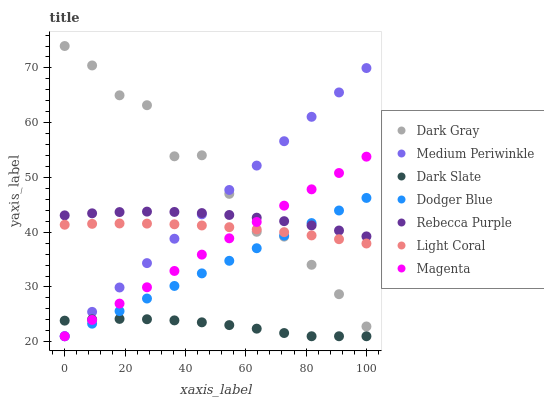Does Dark Slate have the minimum area under the curve?
Answer yes or no. Yes. Does Dark Gray have the maximum area under the curve?
Answer yes or no. Yes. Does Medium Periwinkle have the minimum area under the curve?
Answer yes or no. No. Does Medium Periwinkle have the maximum area under the curve?
Answer yes or no. No. Is Magenta the smoothest?
Answer yes or no. Yes. Is Dark Gray the roughest?
Answer yes or no. Yes. Is Medium Periwinkle the smoothest?
Answer yes or no. No. Is Medium Periwinkle the roughest?
Answer yes or no. No. Does Medium Periwinkle have the lowest value?
Answer yes or no. Yes. Does Dark Gray have the lowest value?
Answer yes or no. No. Does Dark Gray have the highest value?
Answer yes or no. Yes. Does Medium Periwinkle have the highest value?
Answer yes or no. No. Is Dark Slate less than Rebecca Purple?
Answer yes or no. Yes. Is Rebecca Purple greater than Light Coral?
Answer yes or no. Yes. Does Dodger Blue intersect Medium Periwinkle?
Answer yes or no. Yes. Is Dodger Blue less than Medium Periwinkle?
Answer yes or no. No. Is Dodger Blue greater than Medium Periwinkle?
Answer yes or no. No. Does Dark Slate intersect Rebecca Purple?
Answer yes or no. No. 